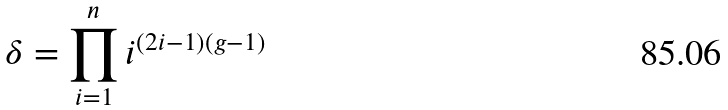Convert formula to latex. <formula><loc_0><loc_0><loc_500><loc_500>\delta = \prod _ { i = 1 } ^ { n } i ^ { ( 2 i - 1 ) ( g - 1 ) }</formula> 